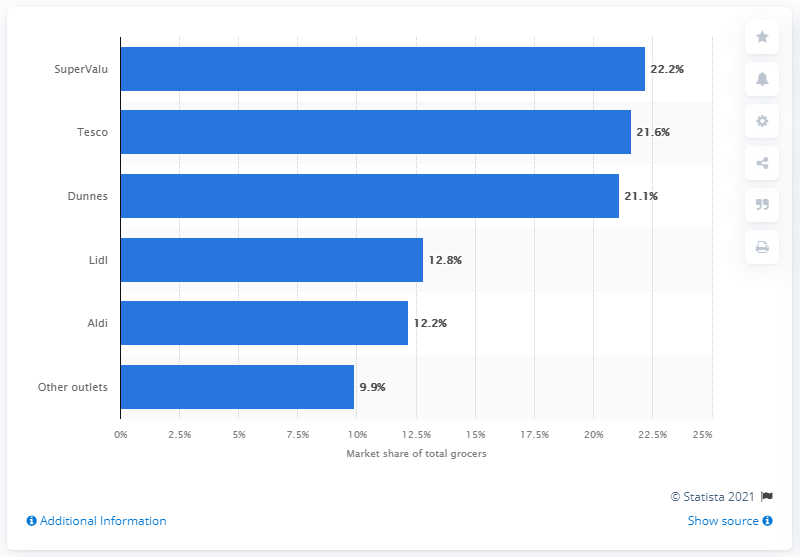Identify some key points in this picture. SuperValu held the highest market share among all grocery stores. According to the data provided, Tesco was followed by SuperValu as the second highest grocery store with a 21.6% market share. 